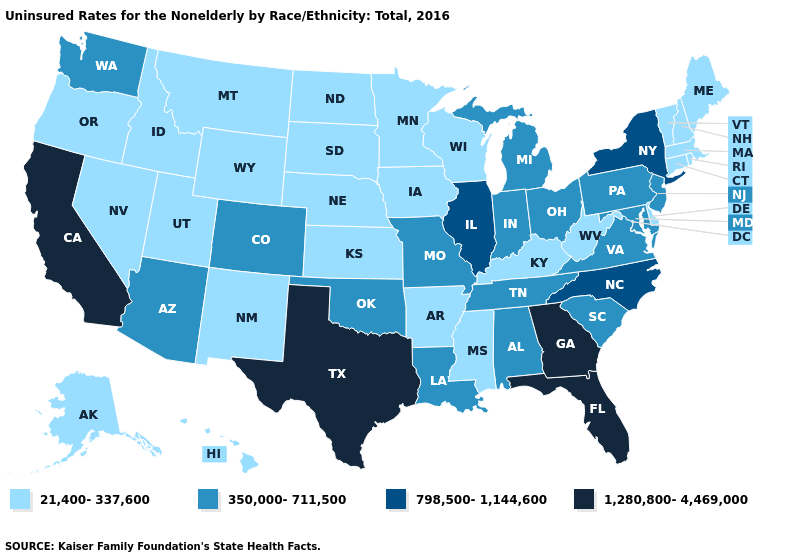Does Colorado have the lowest value in the West?
Keep it brief. No. Name the states that have a value in the range 350,000-711,500?
Keep it brief. Alabama, Arizona, Colorado, Indiana, Louisiana, Maryland, Michigan, Missouri, New Jersey, Ohio, Oklahoma, Pennsylvania, South Carolina, Tennessee, Virginia, Washington. Which states have the highest value in the USA?
Write a very short answer. California, Florida, Georgia, Texas. Does Hawaii have the lowest value in the USA?
Keep it brief. Yes. Name the states that have a value in the range 798,500-1,144,600?
Give a very brief answer. Illinois, New York, North Carolina. Does the map have missing data?
Keep it brief. No. Among the states that border Kentucky , which have the highest value?
Answer briefly. Illinois. Which states have the lowest value in the MidWest?
Short answer required. Iowa, Kansas, Minnesota, Nebraska, North Dakota, South Dakota, Wisconsin. Which states hav the highest value in the West?
Concise answer only. California. Which states have the highest value in the USA?
Be succinct. California, Florida, Georgia, Texas. What is the lowest value in states that border Georgia?
Write a very short answer. 350,000-711,500. What is the highest value in states that border Maine?
Keep it brief. 21,400-337,600. Name the states that have a value in the range 350,000-711,500?
Give a very brief answer. Alabama, Arizona, Colorado, Indiana, Louisiana, Maryland, Michigan, Missouri, New Jersey, Ohio, Oklahoma, Pennsylvania, South Carolina, Tennessee, Virginia, Washington. What is the highest value in the MidWest ?
Concise answer only. 798,500-1,144,600. What is the highest value in the West ?
Be succinct. 1,280,800-4,469,000. 